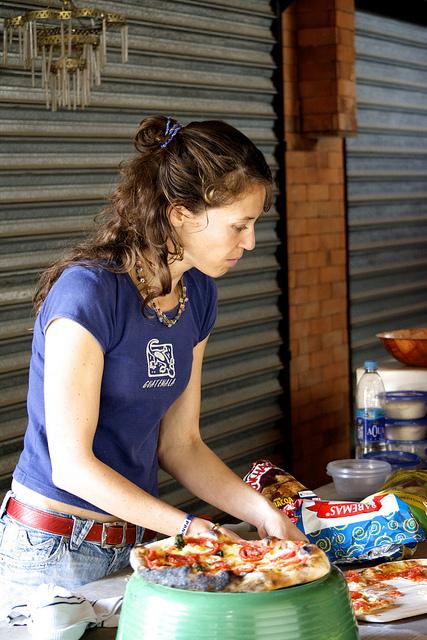What color is her shirt?
Short answer required. Blue. What is above her head?
Write a very short answer. Chandelier. What is round her waist?
Be succinct. Belt. 